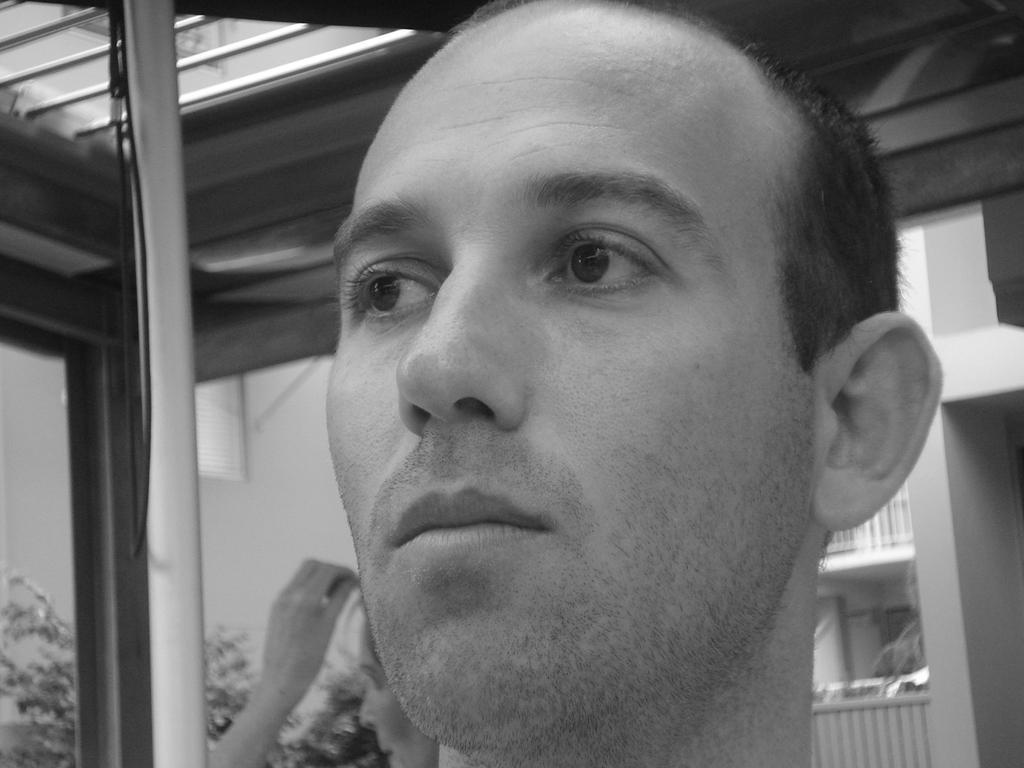Describe this image in one or two sentences. In this image I can see the black and white picture of a person's head. In the background I can see another person, a building, the railing and few trees. 